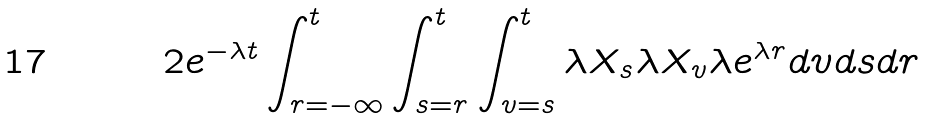<formula> <loc_0><loc_0><loc_500><loc_500>2 e ^ { - \lambda t } \int _ { r = - \infty } ^ { t } \int _ { s = r } ^ { t } \int _ { v = s } ^ { t } \lambda X _ { s } \lambda X _ { v } \lambda e ^ { \lambda r } d v d s d r</formula> 